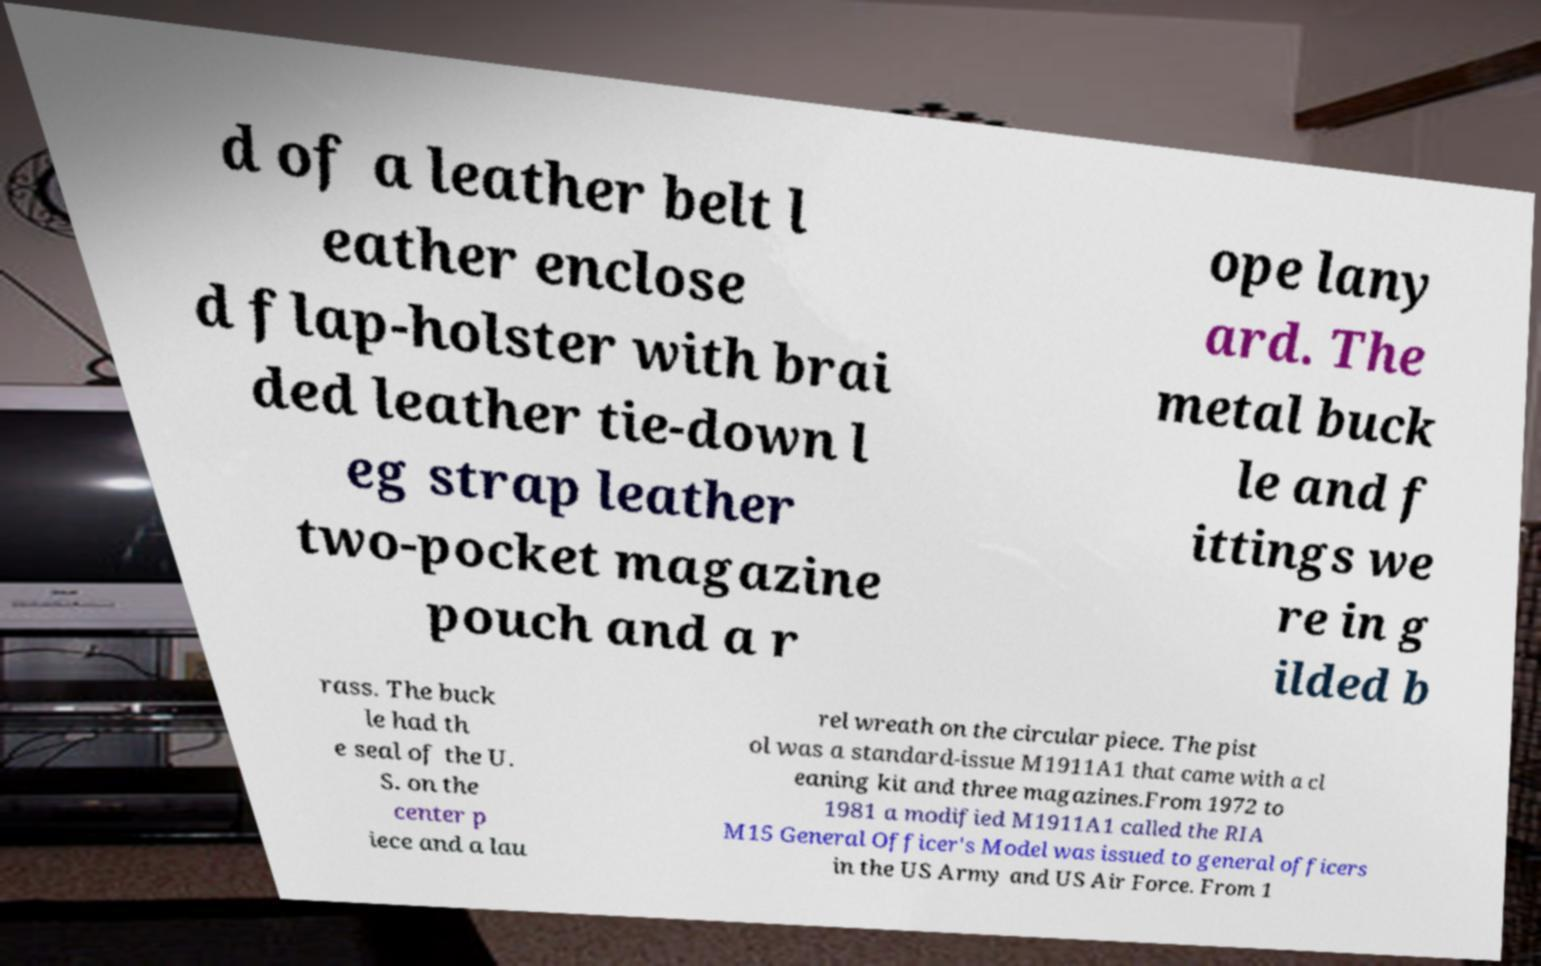Can you accurately transcribe the text from the provided image for me? d of a leather belt l eather enclose d flap-holster with brai ded leather tie-down l eg strap leather two-pocket magazine pouch and a r ope lany ard. The metal buck le and f ittings we re in g ilded b rass. The buck le had th e seal of the U. S. on the center p iece and a lau rel wreath on the circular piece. The pist ol was a standard-issue M1911A1 that came with a cl eaning kit and three magazines.From 1972 to 1981 a modified M1911A1 called the RIA M15 General Officer's Model was issued to general officers in the US Army and US Air Force. From 1 